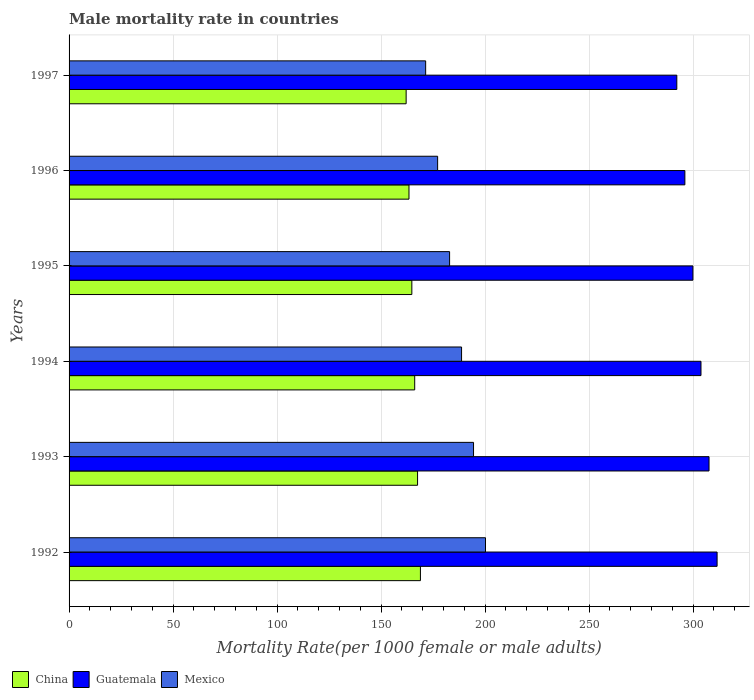How many bars are there on the 5th tick from the top?
Your answer should be compact. 3. What is the label of the 3rd group of bars from the top?
Provide a short and direct response. 1995. In how many cases, is the number of bars for a given year not equal to the number of legend labels?
Provide a succinct answer. 0. What is the male mortality rate in China in 1993?
Make the answer very short. 167.56. Across all years, what is the maximum male mortality rate in China?
Your response must be concise. 168.93. Across all years, what is the minimum male mortality rate in Mexico?
Make the answer very short. 171.45. In which year was the male mortality rate in China minimum?
Give a very brief answer. 1997. What is the total male mortality rate in China in the graph?
Offer a very short reply. 992.98. What is the difference between the male mortality rate in Guatemala in 1994 and that in 1995?
Your response must be concise. 3.87. What is the difference between the male mortality rate in China in 1992 and the male mortality rate in Mexico in 1994?
Keep it short and to the point. -19.78. What is the average male mortality rate in Mexico per year?
Keep it short and to the point. 185.84. In the year 1992, what is the difference between the male mortality rate in China and male mortality rate in Guatemala?
Keep it short and to the point. -142.64. In how many years, is the male mortality rate in Mexico greater than 20 ?
Make the answer very short. 6. What is the ratio of the male mortality rate in China in 1992 to that in 1995?
Make the answer very short. 1.03. Is the male mortality rate in China in 1996 less than that in 1997?
Provide a short and direct response. No. Is the difference between the male mortality rate in China in 1993 and 1997 greater than the difference between the male mortality rate in Guatemala in 1993 and 1997?
Offer a very short reply. No. What is the difference between the highest and the second highest male mortality rate in Mexico?
Ensure brevity in your answer.  5.76. What is the difference between the highest and the lowest male mortality rate in Guatemala?
Offer a terse response. 19.36. In how many years, is the male mortality rate in China greater than the average male mortality rate in China taken over all years?
Offer a terse response. 3. Is the sum of the male mortality rate in China in 1992 and 1995 greater than the maximum male mortality rate in Guatemala across all years?
Your response must be concise. Yes. What does the 1st bar from the bottom in 1995 represents?
Give a very brief answer. China. Is it the case that in every year, the sum of the male mortality rate in Guatemala and male mortality rate in China is greater than the male mortality rate in Mexico?
Provide a succinct answer. Yes. Are all the bars in the graph horizontal?
Provide a short and direct response. Yes. What is the difference between two consecutive major ticks on the X-axis?
Make the answer very short. 50. Are the values on the major ticks of X-axis written in scientific E-notation?
Offer a terse response. No. Does the graph contain grids?
Give a very brief answer. Yes. Where does the legend appear in the graph?
Give a very brief answer. Bottom left. What is the title of the graph?
Give a very brief answer. Male mortality rate in countries. What is the label or title of the X-axis?
Ensure brevity in your answer.  Mortality Rate(per 1000 female or male adults). What is the Mortality Rate(per 1000 female or male adults) of China in 1992?
Offer a very short reply. 168.93. What is the Mortality Rate(per 1000 female or male adults) of Guatemala in 1992?
Offer a terse response. 311.57. What is the Mortality Rate(per 1000 female or male adults) in Mexico in 1992?
Ensure brevity in your answer.  200.22. What is the Mortality Rate(per 1000 female or male adults) in China in 1993?
Ensure brevity in your answer.  167.56. What is the Mortality Rate(per 1000 female or male adults) in Guatemala in 1993?
Ensure brevity in your answer.  307.7. What is the Mortality Rate(per 1000 female or male adults) in Mexico in 1993?
Ensure brevity in your answer.  194.47. What is the Mortality Rate(per 1000 female or male adults) of China in 1994?
Provide a succinct answer. 166.18. What is the Mortality Rate(per 1000 female or male adults) of Guatemala in 1994?
Give a very brief answer. 303.83. What is the Mortality Rate(per 1000 female or male adults) of Mexico in 1994?
Offer a very short reply. 188.71. What is the Mortality Rate(per 1000 female or male adults) in China in 1995?
Your response must be concise. 164.81. What is the Mortality Rate(per 1000 female or male adults) in Guatemala in 1995?
Provide a short and direct response. 299.95. What is the Mortality Rate(per 1000 female or male adults) in Mexico in 1995?
Give a very brief answer. 182.96. What is the Mortality Rate(per 1000 female or male adults) in China in 1996?
Your response must be concise. 163.44. What is the Mortality Rate(per 1000 female or male adults) in Guatemala in 1996?
Give a very brief answer. 296.08. What is the Mortality Rate(per 1000 female or male adults) of Mexico in 1996?
Make the answer very short. 177.2. What is the Mortality Rate(per 1000 female or male adults) in China in 1997?
Your answer should be very brief. 162.06. What is the Mortality Rate(per 1000 female or male adults) in Guatemala in 1997?
Make the answer very short. 292.21. What is the Mortality Rate(per 1000 female or male adults) of Mexico in 1997?
Give a very brief answer. 171.45. Across all years, what is the maximum Mortality Rate(per 1000 female or male adults) in China?
Ensure brevity in your answer.  168.93. Across all years, what is the maximum Mortality Rate(per 1000 female or male adults) in Guatemala?
Ensure brevity in your answer.  311.57. Across all years, what is the maximum Mortality Rate(per 1000 female or male adults) in Mexico?
Offer a terse response. 200.22. Across all years, what is the minimum Mortality Rate(per 1000 female or male adults) of China?
Provide a succinct answer. 162.06. Across all years, what is the minimum Mortality Rate(per 1000 female or male adults) of Guatemala?
Provide a short and direct response. 292.21. Across all years, what is the minimum Mortality Rate(per 1000 female or male adults) in Mexico?
Provide a short and direct response. 171.45. What is the total Mortality Rate(per 1000 female or male adults) in China in the graph?
Make the answer very short. 992.98. What is the total Mortality Rate(per 1000 female or male adults) of Guatemala in the graph?
Ensure brevity in your answer.  1811.34. What is the total Mortality Rate(per 1000 female or male adults) in Mexico in the graph?
Offer a very short reply. 1115.01. What is the difference between the Mortality Rate(per 1000 female or male adults) in China in 1992 and that in 1993?
Ensure brevity in your answer.  1.37. What is the difference between the Mortality Rate(per 1000 female or male adults) in Guatemala in 1992 and that in 1993?
Give a very brief answer. 3.87. What is the difference between the Mortality Rate(per 1000 female or male adults) in Mexico in 1992 and that in 1993?
Your answer should be compact. 5.75. What is the difference between the Mortality Rate(per 1000 female or male adults) in China in 1992 and that in 1994?
Give a very brief answer. 2.75. What is the difference between the Mortality Rate(per 1000 female or male adults) of Guatemala in 1992 and that in 1994?
Your response must be concise. 7.75. What is the difference between the Mortality Rate(per 1000 female or male adults) in Mexico in 1992 and that in 1994?
Your answer should be compact. 11.51. What is the difference between the Mortality Rate(per 1000 female or male adults) of China in 1992 and that in 1995?
Give a very brief answer. 4.12. What is the difference between the Mortality Rate(per 1000 female or male adults) of Guatemala in 1992 and that in 1995?
Provide a short and direct response. 11.62. What is the difference between the Mortality Rate(per 1000 female or male adults) in Mexico in 1992 and that in 1995?
Give a very brief answer. 17.27. What is the difference between the Mortality Rate(per 1000 female or male adults) of China in 1992 and that in 1996?
Offer a terse response. 5.5. What is the difference between the Mortality Rate(per 1000 female or male adults) in Guatemala in 1992 and that in 1996?
Ensure brevity in your answer.  15.49. What is the difference between the Mortality Rate(per 1000 female or male adults) in Mexico in 1992 and that in 1996?
Keep it short and to the point. 23.02. What is the difference between the Mortality Rate(per 1000 female or male adults) in China in 1992 and that in 1997?
Your answer should be very brief. 6.87. What is the difference between the Mortality Rate(per 1000 female or male adults) of Guatemala in 1992 and that in 1997?
Provide a succinct answer. 19.36. What is the difference between the Mortality Rate(per 1000 female or male adults) of Mexico in 1992 and that in 1997?
Provide a succinct answer. 28.78. What is the difference between the Mortality Rate(per 1000 female or male adults) of China in 1993 and that in 1994?
Provide a short and direct response. 1.37. What is the difference between the Mortality Rate(per 1000 female or male adults) in Guatemala in 1993 and that in 1994?
Your response must be concise. 3.87. What is the difference between the Mortality Rate(per 1000 female or male adults) in Mexico in 1993 and that in 1994?
Give a very brief answer. 5.75. What is the difference between the Mortality Rate(per 1000 female or male adults) of China in 1993 and that in 1995?
Offer a very short reply. 2.75. What is the difference between the Mortality Rate(per 1000 female or male adults) in Guatemala in 1993 and that in 1995?
Provide a short and direct response. 7.75. What is the difference between the Mortality Rate(per 1000 female or male adults) in Mexico in 1993 and that in 1995?
Your answer should be very brief. 11.51. What is the difference between the Mortality Rate(per 1000 female or male adults) of China in 1993 and that in 1996?
Offer a terse response. 4.12. What is the difference between the Mortality Rate(per 1000 female or male adults) of Guatemala in 1993 and that in 1996?
Your answer should be compact. 11.62. What is the difference between the Mortality Rate(per 1000 female or male adults) in Mexico in 1993 and that in 1996?
Make the answer very short. 17.27. What is the difference between the Mortality Rate(per 1000 female or male adults) in China in 1993 and that in 1997?
Your answer should be very brief. 5.5. What is the difference between the Mortality Rate(per 1000 female or male adults) of Guatemala in 1993 and that in 1997?
Offer a very short reply. 15.49. What is the difference between the Mortality Rate(per 1000 female or male adults) in Mexico in 1993 and that in 1997?
Offer a very short reply. 23.02. What is the difference between the Mortality Rate(per 1000 female or male adults) of China in 1994 and that in 1995?
Provide a short and direct response. 1.37. What is the difference between the Mortality Rate(per 1000 female or male adults) of Guatemala in 1994 and that in 1995?
Your answer should be very brief. 3.87. What is the difference between the Mortality Rate(per 1000 female or male adults) in Mexico in 1994 and that in 1995?
Offer a terse response. 5.76. What is the difference between the Mortality Rate(per 1000 female or male adults) in China in 1994 and that in 1996?
Your answer should be compact. 2.75. What is the difference between the Mortality Rate(per 1000 female or male adults) of Guatemala in 1994 and that in 1996?
Provide a succinct answer. 7.75. What is the difference between the Mortality Rate(per 1000 female or male adults) in Mexico in 1994 and that in 1996?
Your answer should be very brief. 11.51. What is the difference between the Mortality Rate(per 1000 female or male adults) of China in 1994 and that in 1997?
Give a very brief answer. 4.12. What is the difference between the Mortality Rate(per 1000 female or male adults) of Guatemala in 1994 and that in 1997?
Your response must be concise. 11.62. What is the difference between the Mortality Rate(per 1000 female or male adults) of Mexico in 1994 and that in 1997?
Make the answer very short. 17.27. What is the difference between the Mortality Rate(per 1000 female or male adults) of China in 1995 and that in 1996?
Provide a succinct answer. 1.37. What is the difference between the Mortality Rate(per 1000 female or male adults) in Guatemala in 1995 and that in 1996?
Your answer should be very brief. 3.87. What is the difference between the Mortality Rate(per 1000 female or male adults) of Mexico in 1995 and that in 1996?
Offer a terse response. 5.75. What is the difference between the Mortality Rate(per 1000 female or male adults) in China in 1995 and that in 1997?
Provide a short and direct response. 2.75. What is the difference between the Mortality Rate(per 1000 female or male adults) of Guatemala in 1995 and that in 1997?
Give a very brief answer. 7.75. What is the difference between the Mortality Rate(per 1000 female or male adults) of Mexico in 1995 and that in 1997?
Your answer should be compact. 11.51. What is the difference between the Mortality Rate(per 1000 female or male adults) of China in 1996 and that in 1997?
Keep it short and to the point. 1.37. What is the difference between the Mortality Rate(per 1000 female or male adults) of Guatemala in 1996 and that in 1997?
Offer a very short reply. 3.87. What is the difference between the Mortality Rate(per 1000 female or male adults) of Mexico in 1996 and that in 1997?
Your answer should be very brief. 5.75. What is the difference between the Mortality Rate(per 1000 female or male adults) of China in 1992 and the Mortality Rate(per 1000 female or male adults) of Guatemala in 1993?
Provide a succinct answer. -138.77. What is the difference between the Mortality Rate(per 1000 female or male adults) in China in 1992 and the Mortality Rate(per 1000 female or male adults) in Mexico in 1993?
Offer a terse response. -25.54. What is the difference between the Mortality Rate(per 1000 female or male adults) in Guatemala in 1992 and the Mortality Rate(per 1000 female or male adults) in Mexico in 1993?
Your answer should be compact. 117.11. What is the difference between the Mortality Rate(per 1000 female or male adults) of China in 1992 and the Mortality Rate(per 1000 female or male adults) of Guatemala in 1994?
Provide a succinct answer. -134.9. What is the difference between the Mortality Rate(per 1000 female or male adults) of China in 1992 and the Mortality Rate(per 1000 female or male adults) of Mexico in 1994?
Your response must be concise. -19.78. What is the difference between the Mortality Rate(per 1000 female or male adults) of Guatemala in 1992 and the Mortality Rate(per 1000 female or male adults) of Mexico in 1994?
Your answer should be compact. 122.86. What is the difference between the Mortality Rate(per 1000 female or male adults) in China in 1992 and the Mortality Rate(per 1000 female or male adults) in Guatemala in 1995?
Ensure brevity in your answer.  -131.02. What is the difference between the Mortality Rate(per 1000 female or male adults) in China in 1992 and the Mortality Rate(per 1000 female or male adults) in Mexico in 1995?
Provide a short and direct response. -14.03. What is the difference between the Mortality Rate(per 1000 female or male adults) in Guatemala in 1992 and the Mortality Rate(per 1000 female or male adults) in Mexico in 1995?
Offer a terse response. 128.62. What is the difference between the Mortality Rate(per 1000 female or male adults) of China in 1992 and the Mortality Rate(per 1000 female or male adults) of Guatemala in 1996?
Provide a succinct answer. -127.15. What is the difference between the Mortality Rate(per 1000 female or male adults) of China in 1992 and the Mortality Rate(per 1000 female or male adults) of Mexico in 1996?
Give a very brief answer. -8.27. What is the difference between the Mortality Rate(per 1000 female or male adults) of Guatemala in 1992 and the Mortality Rate(per 1000 female or male adults) of Mexico in 1996?
Give a very brief answer. 134.37. What is the difference between the Mortality Rate(per 1000 female or male adults) of China in 1992 and the Mortality Rate(per 1000 female or male adults) of Guatemala in 1997?
Offer a terse response. -123.28. What is the difference between the Mortality Rate(per 1000 female or male adults) of China in 1992 and the Mortality Rate(per 1000 female or male adults) of Mexico in 1997?
Ensure brevity in your answer.  -2.52. What is the difference between the Mortality Rate(per 1000 female or male adults) in Guatemala in 1992 and the Mortality Rate(per 1000 female or male adults) in Mexico in 1997?
Keep it short and to the point. 140.13. What is the difference between the Mortality Rate(per 1000 female or male adults) of China in 1993 and the Mortality Rate(per 1000 female or male adults) of Guatemala in 1994?
Offer a very short reply. -136.27. What is the difference between the Mortality Rate(per 1000 female or male adults) in China in 1993 and the Mortality Rate(per 1000 female or male adults) in Mexico in 1994?
Your answer should be compact. -21.16. What is the difference between the Mortality Rate(per 1000 female or male adults) of Guatemala in 1993 and the Mortality Rate(per 1000 female or male adults) of Mexico in 1994?
Your answer should be very brief. 118.99. What is the difference between the Mortality Rate(per 1000 female or male adults) in China in 1993 and the Mortality Rate(per 1000 female or male adults) in Guatemala in 1995?
Ensure brevity in your answer.  -132.4. What is the difference between the Mortality Rate(per 1000 female or male adults) of China in 1993 and the Mortality Rate(per 1000 female or male adults) of Mexico in 1995?
Offer a very short reply. -15.4. What is the difference between the Mortality Rate(per 1000 female or male adults) of Guatemala in 1993 and the Mortality Rate(per 1000 female or male adults) of Mexico in 1995?
Give a very brief answer. 124.74. What is the difference between the Mortality Rate(per 1000 female or male adults) of China in 1993 and the Mortality Rate(per 1000 female or male adults) of Guatemala in 1996?
Your response must be concise. -128.52. What is the difference between the Mortality Rate(per 1000 female or male adults) in China in 1993 and the Mortality Rate(per 1000 female or male adults) in Mexico in 1996?
Keep it short and to the point. -9.64. What is the difference between the Mortality Rate(per 1000 female or male adults) of Guatemala in 1993 and the Mortality Rate(per 1000 female or male adults) of Mexico in 1996?
Provide a succinct answer. 130.5. What is the difference between the Mortality Rate(per 1000 female or male adults) of China in 1993 and the Mortality Rate(per 1000 female or male adults) of Guatemala in 1997?
Your answer should be compact. -124.65. What is the difference between the Mortality Rate(per 1000 female or male adults) of China in 1993 and the Mortality Rate(per 1000 female or male adults) of Mexico in 1997?
Offer a terse response. -3.89. What is the difference between the Mortality Rate(per 1000 female or male adults) of Guatemala in 1993 and the Mortality Rate(per 1000 female or male adults) of Mexico in 1997?
Your answer should be compact. 136.25. What is the difference between the Mortality Rate(per 1000 female or male adults) in China in 1994 and the Mortality Rate(per 1000 female or male adults) in Guatemala in 1995?
Offer a terse response. -133.77. What is the difference between the Mortality Rate(per 1000 female or male adults) in China in 1994 and the Mortality Rate(per 1000 female or male adults) in Mexico in 1995?
Provide a succinct answer. -16.77. What is the difference between the Mortality Rate(per 1000 female or male adults) in Guatemala in 1994 and the Mortality Rate(per 1000 female or male adults) in Mexico in 1995?
Make the answer very short. 120.87. What is the difference between the Mortality Rate(per 1000 female or male adults) of China in 1994 and the Mortality Rate(per 1000 female or male adults) of Guatemala in 1996?
Your response must be concise. -129.9. What is the difference between the Mortality Rate(per 1000 female or male adults) of China in 1994 and the Mortality Rate(per 1000 female or male adults) of Mexico in 1996?
Ensure brevity in your answer.  -11.02. What is the difference between the Mortality Rate(per 1000 female or male adults) in Guatemala in 1994 and the Mortality Rate(per 1000 female or male adults) in Mexico in 1996?
Make the answer very short. 126.62. What is the difference between the Mortality Rate(per 1000 female or male adults) of China in 1994 and the Mortality Rate(per 1000 female or male adults) of Guatemala in 1997?
Your response must be concise. -126.02. What is the difference between the Mortality Rate(per 1000 female or male adults) of China in 1994 and the Mortality Rate(per 1000 female or male adults) of Mexico in 1997?
Ensure brevity in your answer.  -5.26. What is the difference between the Mortality Rate(per 1000 female or male adults) of Guatemala in 1994 and the Mortality Rate(per 1000 female or male adults) of Mexico in 1997?
Keep it short and to the point. 132.38. What is the difference between the Mortality Rate(per 1000 female or male adults) of China in 1995 and the Mortality Rate(per 1000 female or male adults) of Guatemala in 1996?
Ensure brevity in your answer.  -131.27. What is the difference between the Mortality Rate(per 1000 female or male adults) in China in 1995 and the Mortality Rate(per 1000 female or male adults) in Mexico in 1996?
Provide a short and direct response. -12.39. What is the difference between the Mortality Rate(per 1000 female or male adults) of Guatemala in 1995 and the Mortality Rate(per 1000 female or male adults) of Mexico in 1996?
Your answer should be compact. 122.75. What is the difference between the Mortality Rate(per 1000 female or male adults) in China in 1995 and the Mortality Rate(per 1000 female or male adults) in Guatemala in 1997?
Ensure brevity in your answer.  -127.4. What is the difference between the Mortality Rate(per 1000 female or male adults) of China in 1995 and the Mortality Rate(per 1000 female or male adults) of Mexico in 1997?
Ensure brevity in your answer.  -6.64. What is the difference between the Mortality Rate(per 1000 female or male adults) in Guatemala in 1995 and the Mortality Rate(per 1000 female or male adults) in Mexico in 1997?
Provide a short and direct response. 128.51. What is the difference between the Mortality Rate(per 1000 female or male adults) of China in 1996 and the Mortality Rate(per 1000 female or male adults) of Guatemala in 1997?
Your response must be concise. -128.77. What is the difference between the Mortality Rate(per 1000 female or male adults) in China in 1996 and the Mortality Rate(per 1000 female or male adults) in Mexico in 1997?
Provide a succinct answer. -8.01. What is the difference between the Mortality Rate(per 1000 female or male adults) in Guatemala in 1996 and the Mortality Rate(per 1000 female or male adults) in Mexico in 1997?
Provide a short and direct response. 124.63. What is the average Mortality Rate(per 1000 female or male adults) in China per year?
Provide a succinct answer. 165.5. What is the average Mortality Rate(per 1000 female or male adults) of Guatemala per year?
Make the answer very short. 301.89. What is the average Mortality Rate(per 1000 female or male adults) of Mexico per year?
Make the answer very short. 185.84. In the year 1992, what is the difference between the Mortality Rate(per 1000 female or male adults) in China and Mortality Rate(per 1000 female or male adults) in Guatemala?
Give a very brief answer. -142.64. In the year 1992, what is the difference between the Mortality Rate(per 1000 female or male adults) in China and Mortality Rate(per 1000 female or male adults) in Mexico?
Offer a terse response. -31.29. In the year 1992, what is the difference between the Mortality Rate(per 1000 female or male adults) in Guatemala and Mortality Rate(per 1000 female or male adults) in Mexico?
Ensure brevity in your answer.  111.35. In the year 1993, what is the difference between the Mortality Rate(per 1000 female or male adults) in China and Mortality Rate(per 1000 female or male adults) in Guatemala?
Offer a terse response. -140.14. In the year 1993, what is the difference between the Mortality Rate(per 1000 female or male adults) in China and Mortality Rate(per 1000 female or male adults) in Mexico?
Ensure brevity in your answer.  -26.91. In the year 1993, what is the difference between the Mortality Rate(per 1000 female or male adults) of Guatemala and Mortality Rate(per 1000 female or male adults) of Mexico?
Your answer should be compact. 113.23. In the year 1994, what is the difference between the Mortality Rate(per 1000 female or male adults) in China and Mortality Rate(per 1000 female or male adults) in Guatemala?
Keep it short and to the point. -137.64. In the year 1994, what is the difference between the Mortality Rate(per 1000 female or male adults) in China and Mortality Rate(per 1000 female or male adults) in Mexico?
Offer a very short reply. -22.53. In the year 1994, what is the difference between the Mortality Rate(per 1000 female or male adults) of Guatemala and Mortality Rate(per 1000 female or male adults) of Mexico?
Your answer should be compact. 115.11. In the year 1995, what is the difference between the Mortality Rate(per 1000 female or male adults) in China and Mortality Rate(per 1000 female or male adults) in Guatemala?
Provide a succinct answer. -135.14. In the year 1995, what is the difference between the Mortality Rate(per 1000 female or male adults) of China and Mortality Rate(per 1000 female or male adults) of Mexico?
Your response must be concise. -18.15. In the year 1995, what is the difference between the Mortality Rate(per 1000 female or male adults) in Guatemala and Mortality Rate(per 1000 female or male adults) in Mexico?
Ensure brevity in your answer.  117. In the year 1996, what is the difference between the Mortality Rate(per 1000 female or male adults) of China and Mortality Rate(per 1000 female or male adults) of Guatemala?
Your response must be concise. -132.65. In the year 1996, what is the difference between the Mortality Rate(per 1000 female or male adults) of China and Mortality Rate(per 1000 female or male adults) of Mexico?
Your answer should be compact. -13.77. In the year 1996, what is the difference between the Mortality Rate(per 1000 female or male adults) in Guatemala and Mortality Rate(per 1000 female or male adults) in Mexico?
Your response must be concise. 118.88. In the year 1997, what is the difference between the Mortality Rate(per 1000 female or male adults) of China and Mortality Rate(per 1000 female or male adults) of Guatemala?
Give a very brief answer. -130.15. In the year 1997, what is the difference between the Mortality Rate(per 1000 female or male adults) in China and Mortality Rate(per 1000 female or male adults) in Mexico?
Your response must be concise. -9.38. In the year 1997, what is the difference between the Mortality Rate(per 1000 female or male adults) of Guatemala and Mortality Rate(per 1000 female or male adults) of Mexico?
Your response must be concise. 120.76. What is the ratio of the Mortality Rate(per 1000 female or male adults) of China in 1992 to that in 1993?
Offer a very short reply. 1.01. What is the ratio of the Mortality Rate(per 1000 female or male adults) in Guatemala in 1992 to that in 1993?
Your response must be concise. 1.01. What is the ratio of the Mortality Rate(per 1000 female or male adults) in Mexico in 1992 to that in 1993?
Your response must be concise. 1.03. What is the ratio of the Mortality Rate(per 1000 female or male adults) in China in 1992 to that in 1994?
Keep it short and to the point. 1.02. What is the ratio of the Mortality Rate(per 1000 female or male adults) of Guatemala in 1992 to that in 1994?
Offer a very short reply. 1.03. What is the ratio of the Mortality Rate(per 1000 female or male adults) of Mexico in 1992 to that in 1994?
Your answer should be very brief. 1.06. What is the ratio of the Mortality Rate(per 1000 female or male adults) in Guatemala in 1992 to that in 1995?
Provide a short and direct response. 1.04. What is the ratio of the Mortality Rate(per 1000 female or male adults) of Mexico in 1992 to that in 1995?
Provide a succinct answer. 1.09. What is the ratio of the Mortality Rate(per 1000 female or male adults) in China in 1992 to that in 1996?
Provide a short and direct response. 1.03. What is the ratio of the Mortality Rate(per 1000 female or male adults) of Guatemala in 1992 to that in 1996?
Provide a short and direct response. 1.05. What is the ratio of the Mortality Rate(per 1000 female or male adults) in Mexico in 1992 to that in 1996?
Ensure brevity in your answer.  1.13. What is the ratio of the Mortality Rate(per 1000 female or male adults) in China in 1992 to that in 1997?
Ensure brevity in your answer.  1.04. What is the ratio of the Mortality Rate(per 1000 female or male adults) in Guatemala in 1992 to that in 1997?
Provide a short and direct response. 1.07. What is the ratio of the Mortality Rate(per 1000 female or male adults) in Mexico in 1992 to that in 1997?
Your answer should be very brief. 1.17. What is the ratio of the Mortality Rate(per 1000 female or male adults) of China in 1993 to that in 1994?
Your answer should be very brief. 1.01. What is the ratio of the Mortality Rate(per 1000 female or male adults) in Guatemala in 1993 to that in 1994?
Your answer should be compact. 1.01. What is the ratio of the Mortality Rate(per 1000 female or male adults) of Mexico in 1993 to that in 1994?
Your response must be concise. 1.03. What is the ratio of the Mortality Rate(per 1000 female or male adults) in China in 1993 to that in 1995?
Your answer should be compact. 1.02. What is the ratio of the Mortality Rate(per 1000 female or male adults) of Guatemala in 1993 to that in 1995?
Ensure brevity in your answer.  1.03. What is the ratio of the Mortality Rate(per 1000 female or male adults) in Mexico in 1993 to that in 1995?
Your response must be concise. 1.06. What is the ratio of the Mortality Rate(per 1000 female or male adults) in China in 1993 to that in 1996?
Give a very brief answer. 1.03. What is the ratio of the Mortality Rate(per 1000 female or male adults) in Guatemala in 1993 to that in 1996?
Make the answer very short. 1.04. What is the ratio of the Mortality Rate(per 1000 female or male adults) in Mexico in 1993 to that in 1996?
Make the answer very short. 1.1. What is the ratio of the Mortality Rate(per 1000 female or male adults) of China in 1993 to that in 1997?
Your answer should be very brief. 1.03. What is the ratio of the Mortality Rate(per 1000 female or male adults) in Guatemala in 1993 to that in 1997?
Your answer should be very brief. 1.05. What is the ratio of the Mortality Rate(per 1000 female or male adults) in Mexico in 1993 to that in 1997?
Your response must be concise. 1.13. What is the ratio of the Mortality Rate(per 1000 female or male adults) of China in 1994 to that in 1995?
Provide a succinct answer. 1.01. What is the ratio of the Mortality Rate(per 1000 female or male adults) of Guatemala in 1994 to that in 1995?
Offer a terse response. 1.01. What is the ratio of the Mortality Rate(per 1000 female or male adults) in Mexico in 1994 to that in 1995?
Provide a short and direct response. 1.03. What is the ratio of the Mortality Rate(per 1000 female or male adults) of China in 1994 to that in 1996?
Keep it short and to the point. 1.02. What is the ratio of the Mortality Rate(per 1000 female or male adults) in Guatemala in 1994 to that in 1996?
Offer a very short reply. 1.03. What is the ratio of the Mortality Rate(per 1000 female or male adults) in Mexico in 1994 to that in 1996?
Make the answer very short. 1.06. What is the ratio of the Mortality Rate(per 1000 female or male adults) in China in 1994 to that in 1997?
Offer a terse response. 1.03. What is the ratio of the Mortality Rate(per 1000 female or male adults) in Guatemala in 1994 to that in 1997?
Your answer should be compact. 1.04. What is the ratio of the Mortality Rate(per 1000 female or male adults) in Mexico in 1994 to that in 1997?
Give a very brief answer. 1.1. What is the ratio of the Mortality Rate(per 1000 female or male adults) of China in 1995 to that in 1996?
Offer a very short reply. 1.01. What is the ratio of the Mortality Rate(per 1000 female or male adults) of Guatemala in 1995 to that in 1996?
Ensure brevity in your answer.  1.01. What is the ratio of the Mortality Rate(per 1000 female or male adults) in Mexico in 1995 to that in 1996?
Your answer should be very brief. 1.03. What is the ratio of the Mortality Rate(per 1000 female or male adults) of Guatemala in 1995 to that in 1997?
Give a very brief answer. 1.03. What is the ratio of the Mortality Rate(per 1000 female or male adults) of Mexico in 1995 to that in 1997?
Provide a succinct answer. 1.07. What is the ratio of the Mortality Rate(per 1000 female or male adults) in China in 1996 to that in 1997?
Keep it short and to the point. 1.01. What is the ratio of the Mortality Rate(per 1000 female or male adults) in Guatemala in 1996 to that in 1997?
Provide a short and direct response. 1.01. What is the ratio of the Mortality Rate(per 1000 female or male adults) of Mexico in 1996 to that in 1997?
Your response must be concise. 1.03. What is the difference between the highest and the second highest Mortality Rate(per 1000 female or male adults) of China?
Ensure brevity in your answer.  1.37. What is the difference between the highest and the second highest Mortality Rate(per 1000 female or male adults) of Guatemala?
Offer a very short reply. 3.87. What is the difference between the highest and the second highest Mortality Rate(per 1000 female or male adults) of Mexico?
Provide a succinct answer. 5.75. What is the difference between the highest and the lowest Mortality Rate(per 1000 female or male adults) in China?
Ensure brevity in your answer.  6.87. What is the difference between the highest and the lowest Mortality Rate(per 1000 female or male adults) in Guatemala?
Offer a terse response. 19.36. What is the difference between the highest and the lowest Mortality Rate(per 1000 female or male adults) in Mexico?
Offer a very short reply. 28.78. 